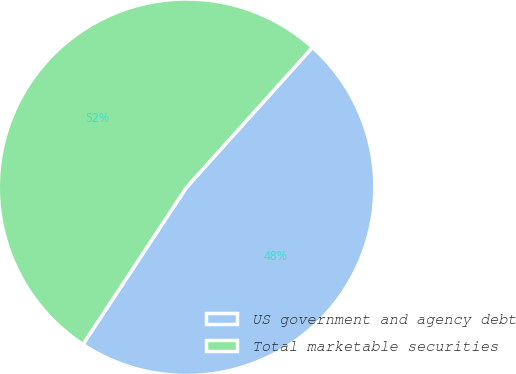Convert chart to OTSL. <chart><loc_0><loc_0><loc_500><loc_500><pie_chart><fcel>US government and agency debt<fcel>Total marketable securities<nl><fcel>47.62%<fcel>52.38%<nl></chart> 